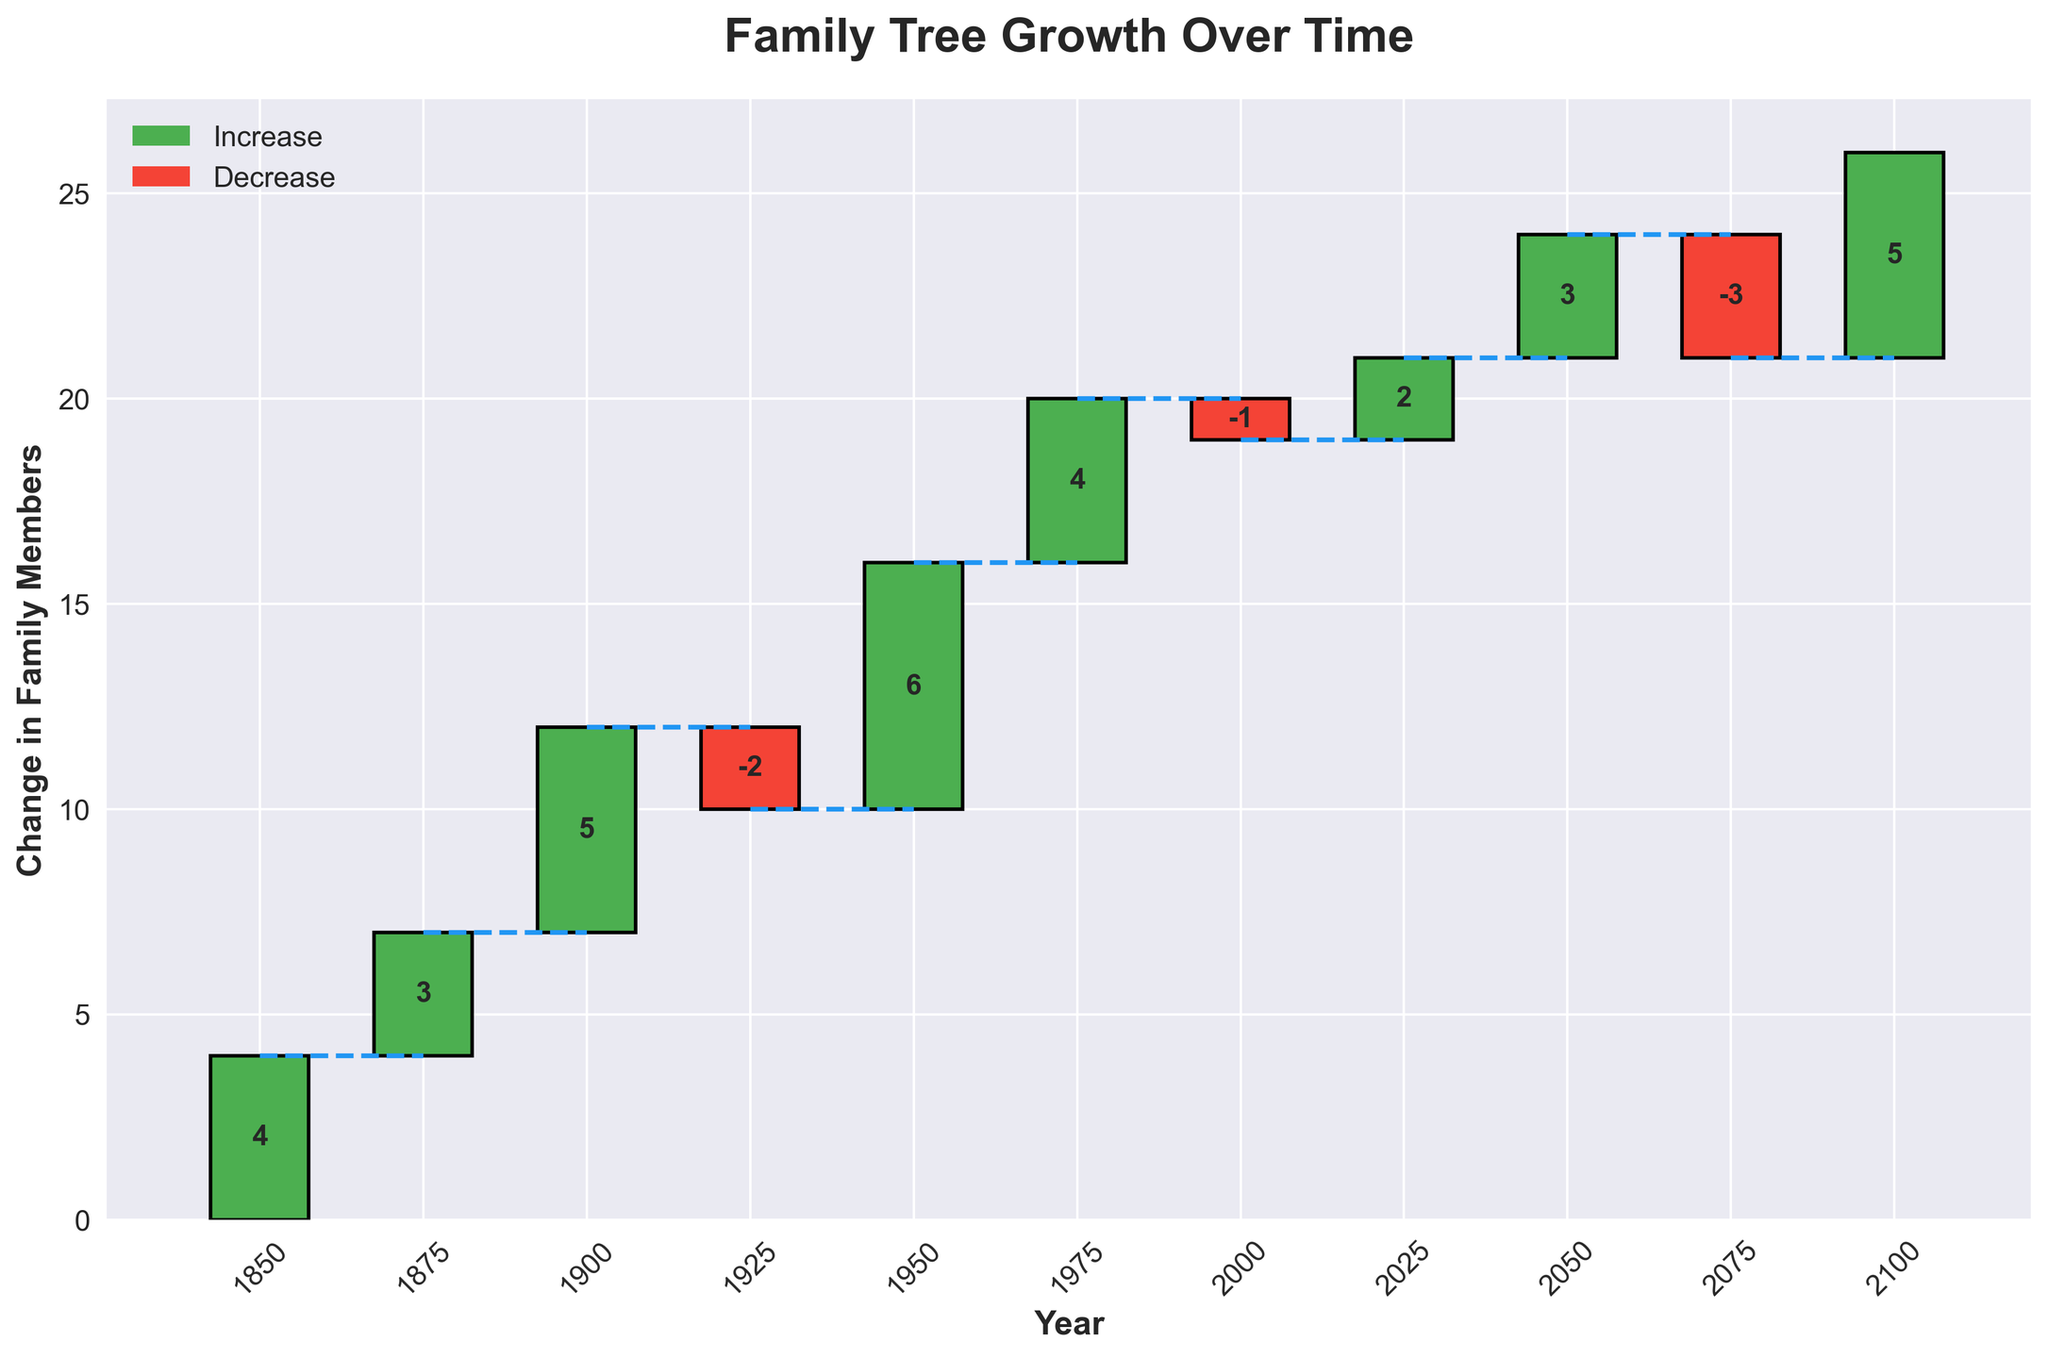What is the title of the chart? The title of the chart is usually displayed at the top of the figure. In this case, it is clearly labeled as "Family Tree Growth Over Time."
Answer: Family Tree Growth Over Time How many family branches experienced a decline? To identify the branches with decline, look for bars colored in red, which indicate a decrease in family members. Carefully count these bars in the chart.
Answer: 3 Which year had the highest increase in family members? To find the year with the highest increase, look for the tallest green bar in the chart and note the year displayed underneath it.
Answer: 1950 What is the cumulative change in family members from 1850 to 2100? Calculate the cumulative change by summing all the values provided on the bars from 1850 to 2100 (positive and negative changes included). This sum gives the overall change over the period.
Answer: 26 Which family branch had the smallest increase? Examine the chart to identify the smallest green bar (indicating an increase) and note the family branch associated with it.
Answer: Anderson What is the net change in family members between 1850 and 1950? Identify the changes in these years: 4 (1850), 3 (1875), 5 (1900), -2 (1925), and 6 (1950). Sum these values: 4 + 3 + 5 - 2 + 6 = 16.
Answer: 16 How many family branches experienced changes after the year 2000? Count the bars representing changes in the years 2025 and 2050 and 2075 and 2100, as they are all after the year 2000.
Answer: 4 Which family branch had a change in 1925 and was it positive or negative? Find the bar corresponding to the year 1925 and observe its color and value. The red color and the value below the x-axis indicate a negative change.
Answer: Brown, negative Compare the total increase in family members between 1850-1900 and 1950-2000. Which period saw a greater increase? Calculate the sum of changes for 1850-1900: 4 + 3 + 5 = 12. Calculate the sum of changes for 1950-2000: 6 + 4 - 1 = 9. Compare these totals to determine which period had a greater increase.
Answer: 1850-1900 What is the pattern of changes observed in the family branches over time? Observe the sequence and type of changes (increase or decrease) over time by looking at the bar heights and colors. The pattern shows overall growth with occasional declines.
Answer: Overall growth with occasional declines 